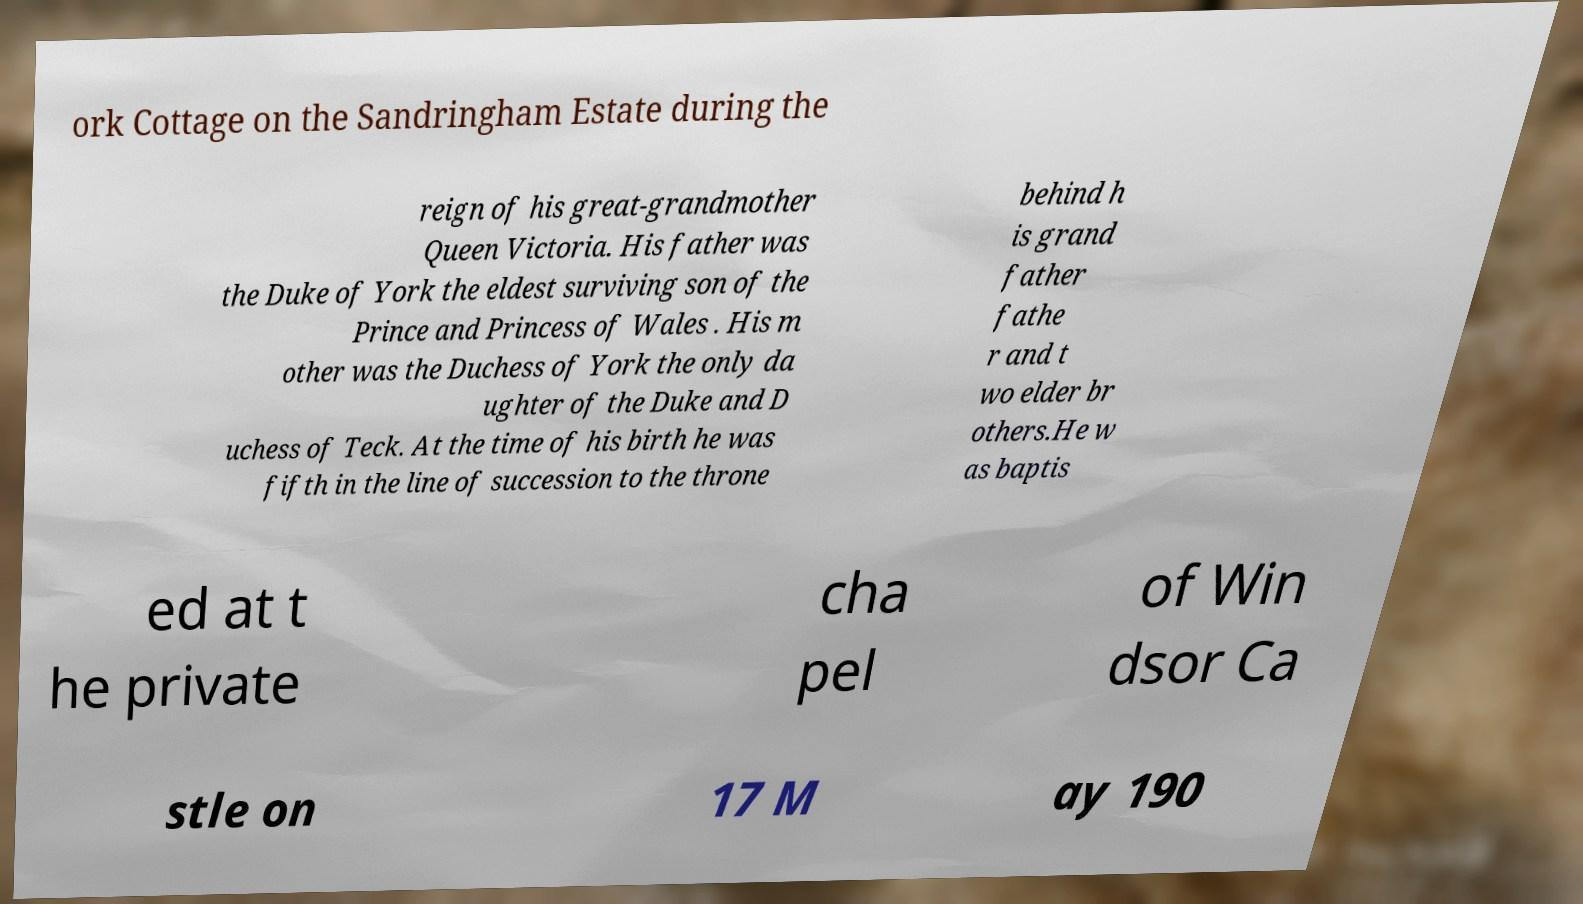For documentation purposes, I need the text within this image transcribed. Could you provide that? ork Cottage on the Sandringham Estate during the reign of his great-grandmother Queen Victoria. His father was the Duke of York the eldest surviving son of the Prince and Princess of Wales . His m other was the Duchess of York the only da ughter of the Duke and D uchess of Teck. At the time of his birth he was fifth in the line of succession to the throne behind h is grand father fathe r and t wo elder br others.He w as baptis ed at t he private cha pel of Win dsor Ca stle on 17 M ay 190 